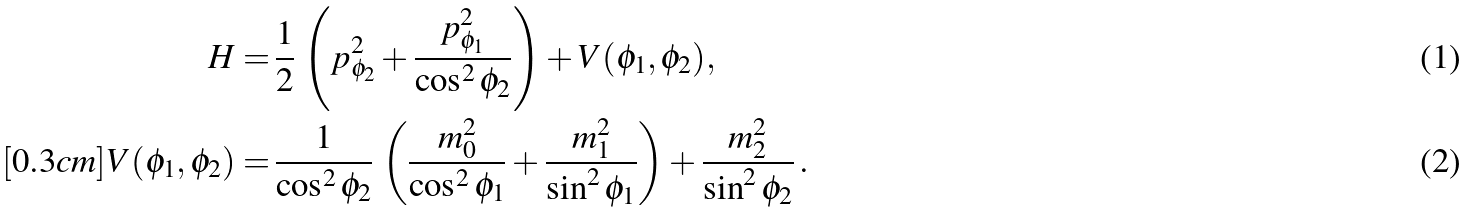Convert formula to latex. <formula><loc_0><loc_0><loc_500><loc_500>H = & \, \frac { 1 } { 2 } \, \left ( p _ { \phi _ { 2 } } ^ { 2 } + \frac { p _ { \phi _ { 1 } } ^ { 2 } } { \cos ^ { 2 } \phi _ { 2 } } \right ) + V ( \phi _ { 1 } , \phi _ { 2 } ) , \\ [ 0 . 3 c m ] V ( \phi _ { 1 } , \phi _ { 2 } ) = & \, \frac { 1 } { \cos ^ { 2 } \phi _ { 2 } } \, \left ( \frac { m _ { 0 } ^ { 2 } } { \cos ^ { 2 } \phi _ { 1 } } + \frac { m _ { 1 } ^ { 2 } } { \sin ^ { 2 } \phi _ { 1 } } \right ) + \frac { m _ { 2 } ^ { 2 } } { \sin ^ { 2 } \phi _ { 2 } } \, .</formula> 